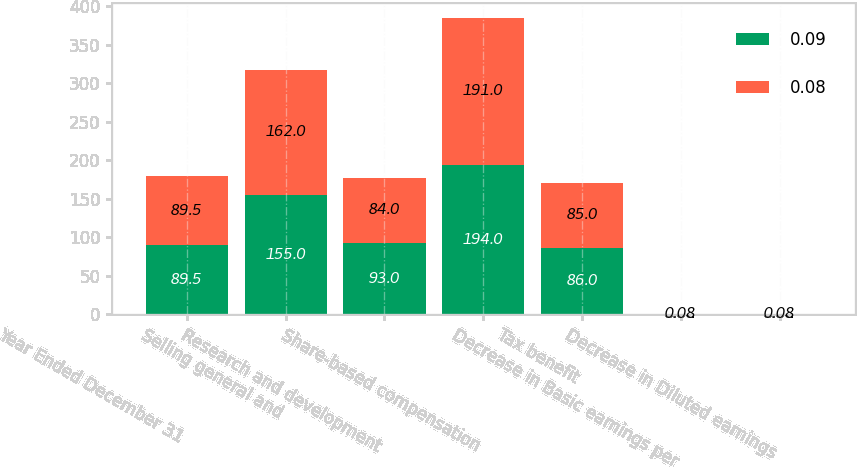Convert chart to OTSL. <chart><loc_0><loc_0><loc_500><loc_500><stacked_bar_chart><ecel><fcel>Year Ended December 31<fcel>Selling general and<fcel>Research and development<fcel>Share-based compensation<fcel>Tax benefit<fcel>Decrease in Basic earnings per<fcel>Decrease in Diluted earnings<nl><fcel>0.09<fcel>89.5<fcel>155<fcel>93<fcel>194<fcel>86<fcel>0.09<fcel>0.09<nl><fcel>0.08<fcel>89.5<fcel>162<fcel>84<fcel>191<fcel>85<fcel>0.08<fcel>0.08<nl></chart> 